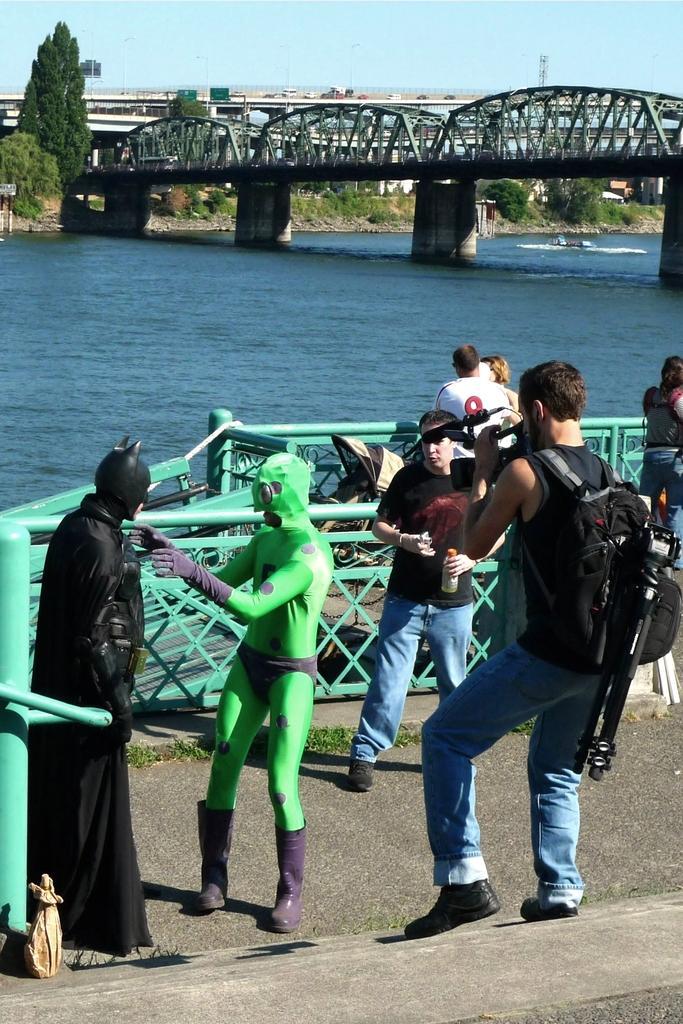Can you describe this image briefly? In this picture we can see a group of people standing on the ground where some of them wore costumes, stroller, bridge, fence, trees, water and in the background we can see the sky. 